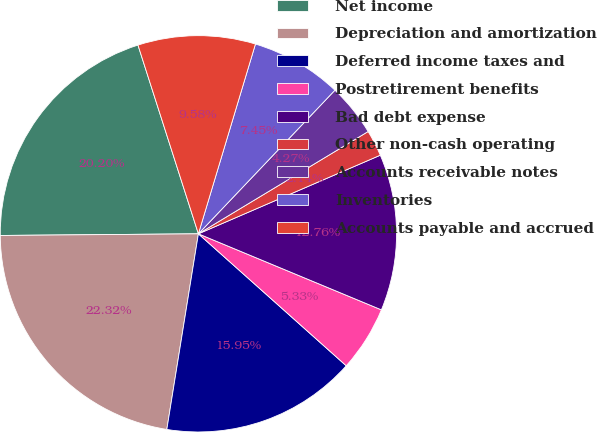Convert chart. <chart><loc_0><loc_0><loc_500><loc_500><pie_chart><fcel>Net income<fcel>Depreciation and amortization<fcel>Deferred income taxes and<fcel>Postretirement benefits<fcel>Bad debt expense<fcel>Other non-cash operating<fcel>Accounts receivable notes<fcel>Inventories<fcel>Accounts payable and accrued<nl><fcel>20.2%<fcel>22.32%<fcel>15.95%<fcel>5.33%<fcel>12.76%<fcel>2.14%<fcel>4.27%<fcel>7.45%<fcel>9.58%<nl></chart> 